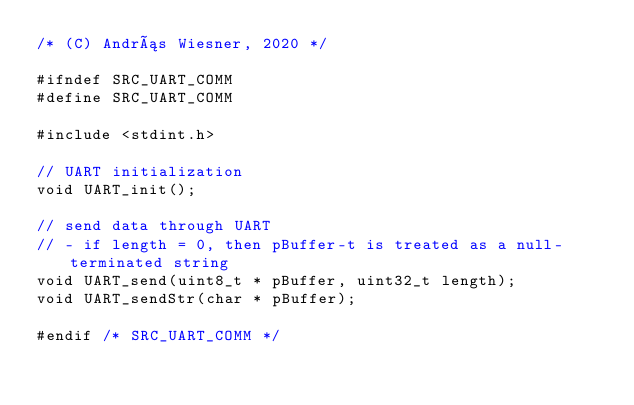<code> <loc_0><loc_0><loc_500><loc_500><_C_>/* (C) András Wiesner, 2020 */

#ifndef SRC_UART_COMM
#define SRC_UART_COMM

#include <stdint.h>

// UART initialization
void UART_init();

// send data through UART
// - if length = 0, then pBuffer-t is treated as a null-terminated string
void UART_send(uint8_t * pBuffer, uint32_t length);
void UART_sendStr(char * pBuffer);

#endif /* SRC_UART_COMM */
</code> 